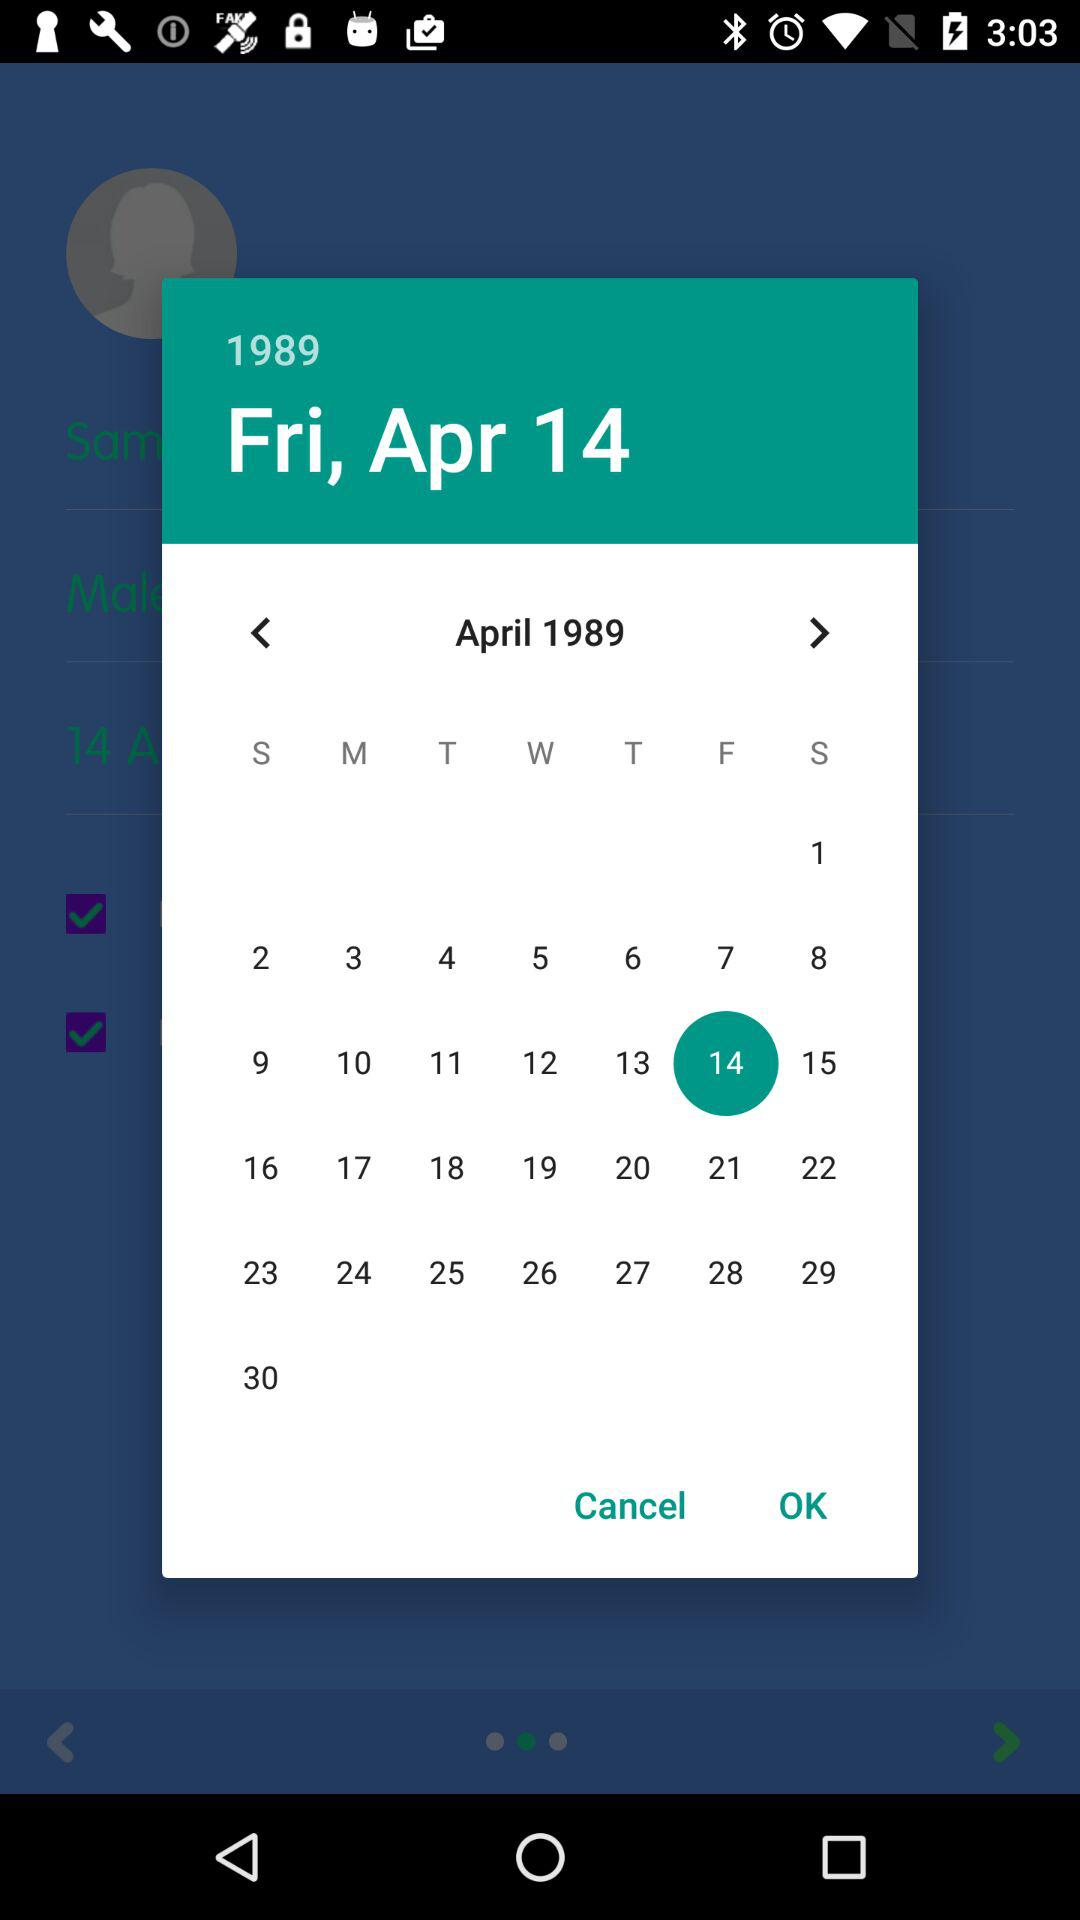What is the selected year? The selected year is 1989. 